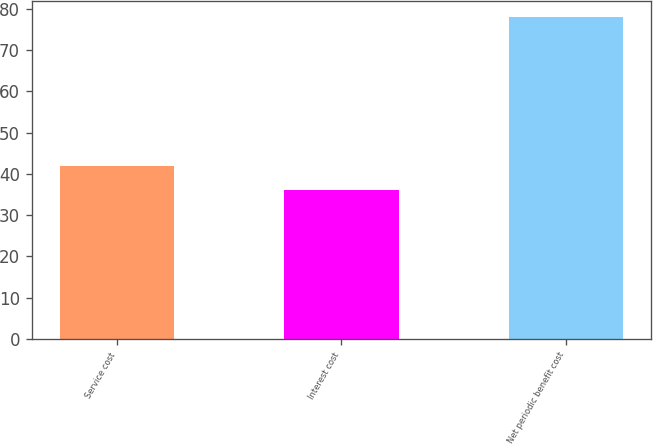<chart> <loc_0><loc_0><loc_500><loc_500><bar_chart><fcel>Service cost<fcel>Interest cost<fcel>Net periodic benefit cost<nl><fcel>42<fcel>36<fcel>78<nl></chart> 